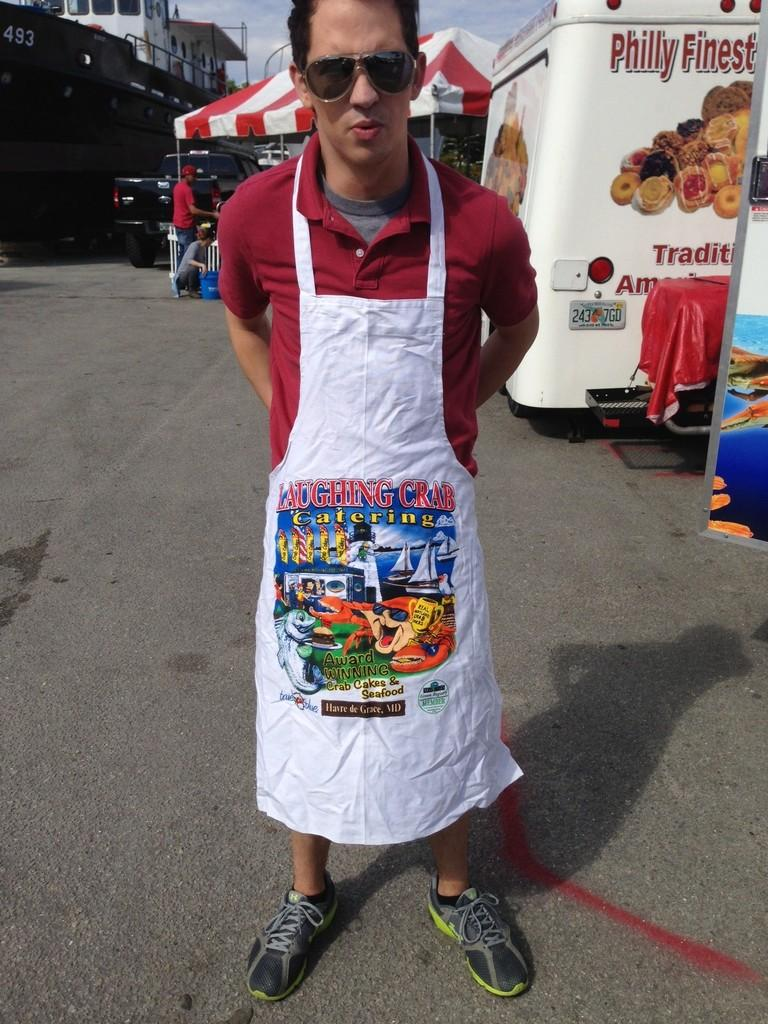<image>
Relay a brief, clear account of the picture shown. The owners of this catering company believe that crabs can laugh. 